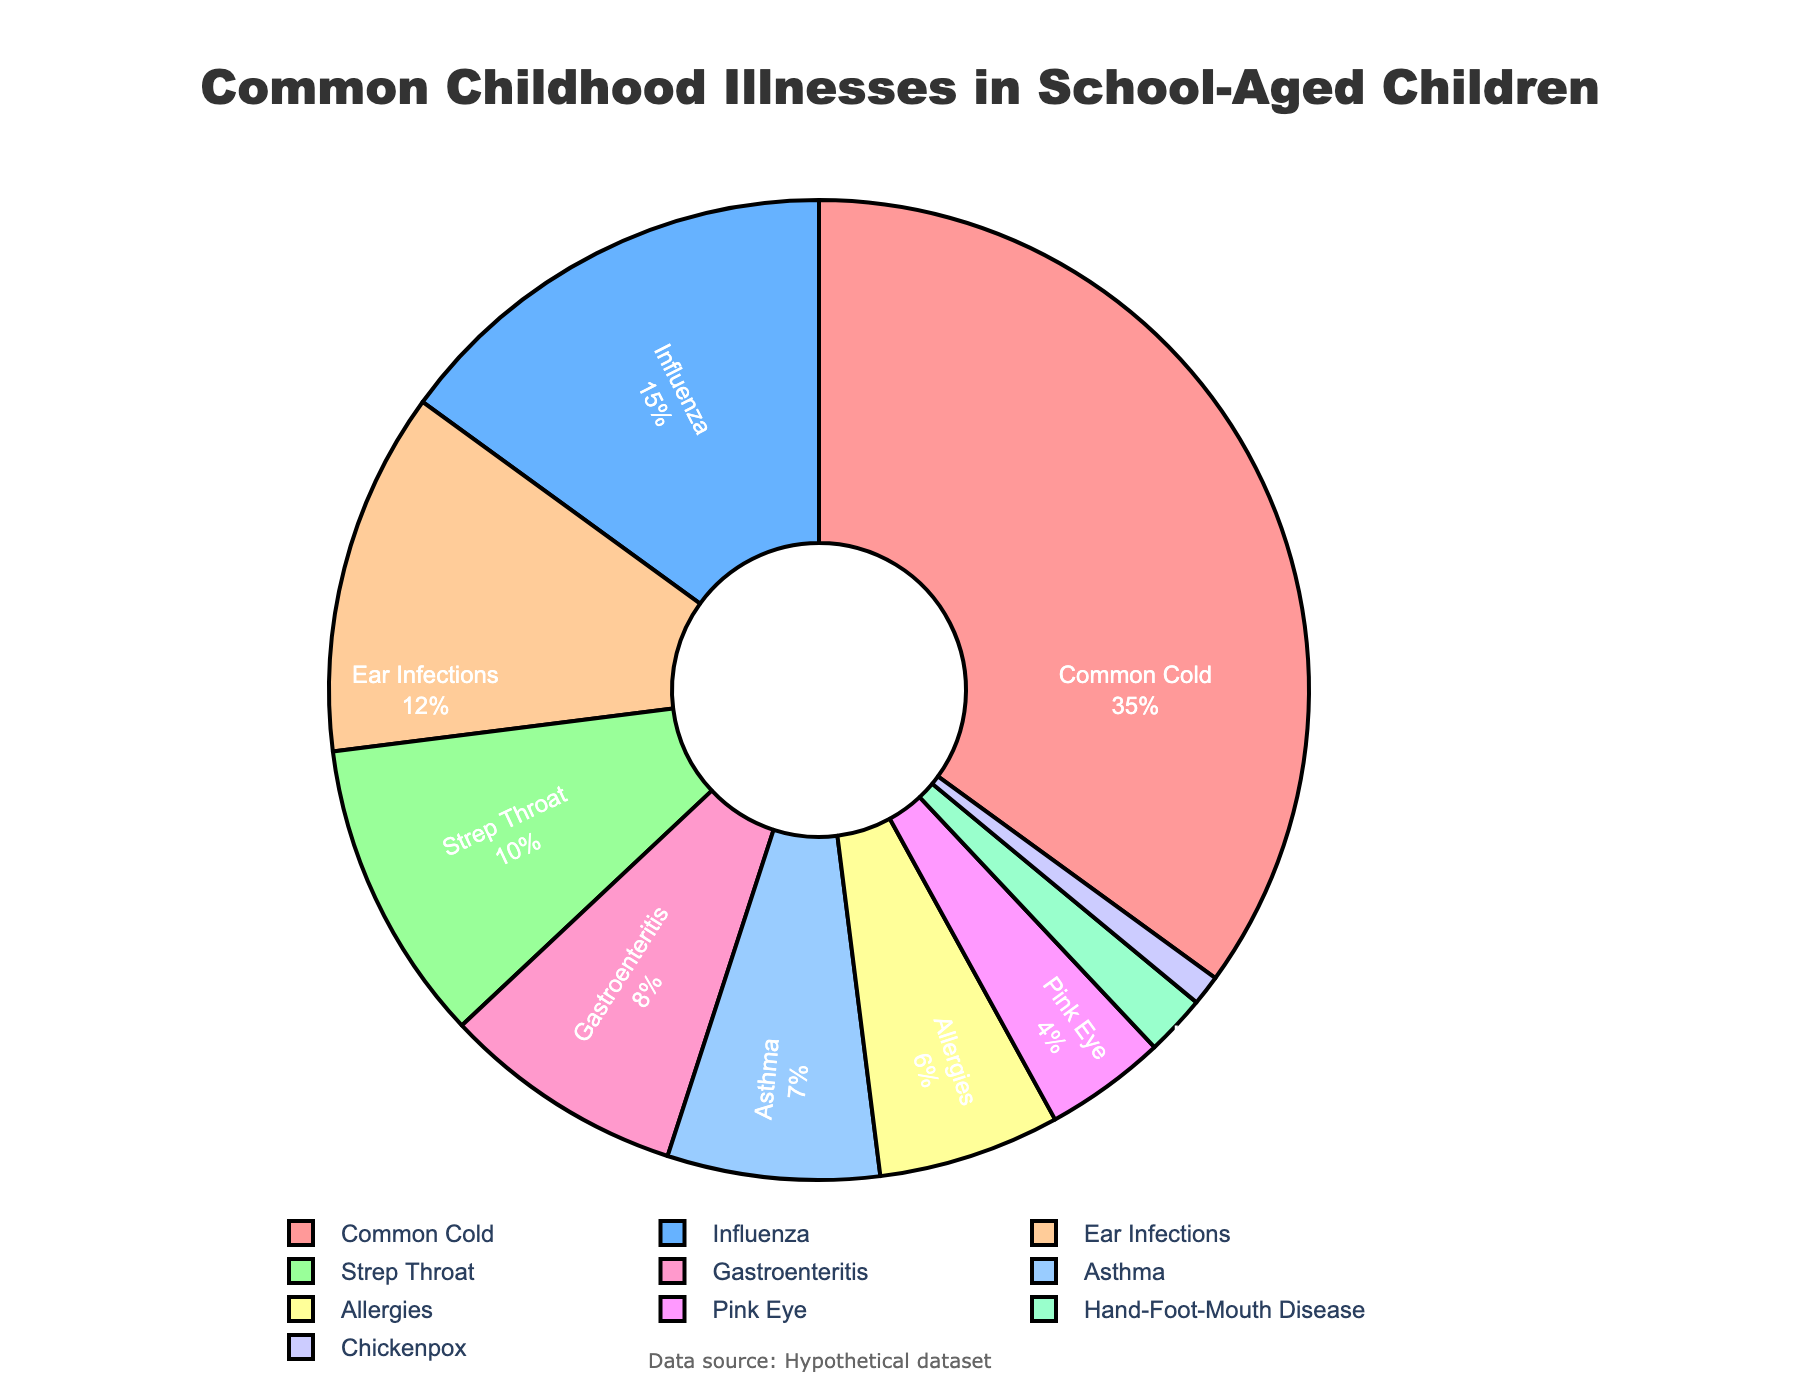What is the most common childhood illness according to the chart? The chart shows that the Common Cold has the largest segment, indicating it has the highest prevalence at 35%.
Answer: Common Cold Which illness has roughly half the prevalence of the Common Cold? The Common Cold has a prevalence of 35%. Influenza, with a prevalence of 15%, is roughly half the prevalence of the Common Cold.
Answer: Influenza How much more common are Ear Infections compared to Pink Eye? The prevalence of Ear Infections is 12%, while the prevalence of Pink Eye is 4%. The difference is 12% - 4% = 8%.
Answer: 8% What percentage of childhood illnesses do Strep Throat and Gastroenteritis together account for? Strep Throat has a prevalence of 10%, and Gastroenteritis has a prevalence of 8%. Together, they account for 10% + 8% = 18%.
Answer: 18% Which illnesses have a prevalence of less than 5%? The chart shows that Pink Eye (4%), Hand-Foot-Mouth Disease (2%), and Chickenpox (1%) each have a prevalence of less than 5%.
Answer: Pink Eye, Hand-Foot-Mouth Disease, Chickenpox How does the prevalence of Asthma compare to that of Allergies? The chart shows Asthma has a prevalence of 7%, while Allergies have a prevalence of 6%. Asthma is slightly more common than Allergies.
Answer: Asthma is more common What is the combined prevalence of illnesses with less than 10% prevalence? Adding the prevalence rates: Gastroenteritis (8%), Asthma (7%), Allergies (6%), Pink Eye (4%), Hand-Foot-Mouth Disease (2%), and Chickenpox (1%), we get 8% + 7% + 6% + 4% + 2% + 1% = 28%.
Answer: 28% Identify the illness represented by a light blue color segment. The light blue color segment in the chart corresponds to Influenza, which has a prevalence of 15%.
Answer: Influenza Which illness accounts for the smallest percentage? The smallest segment in the chart corresponds to Chickenpox, which has a prevalence of 1%.
Answer: Chickenpox What illnesses together account for more than 50% of the total? The Common Cold (35%) and Influenza (15%) together sum up to 35% + 15% = 50%. Including Ear Infections (12%) would exceed 50%.
Answer: Common Cold, Influenza, Ear Infections 